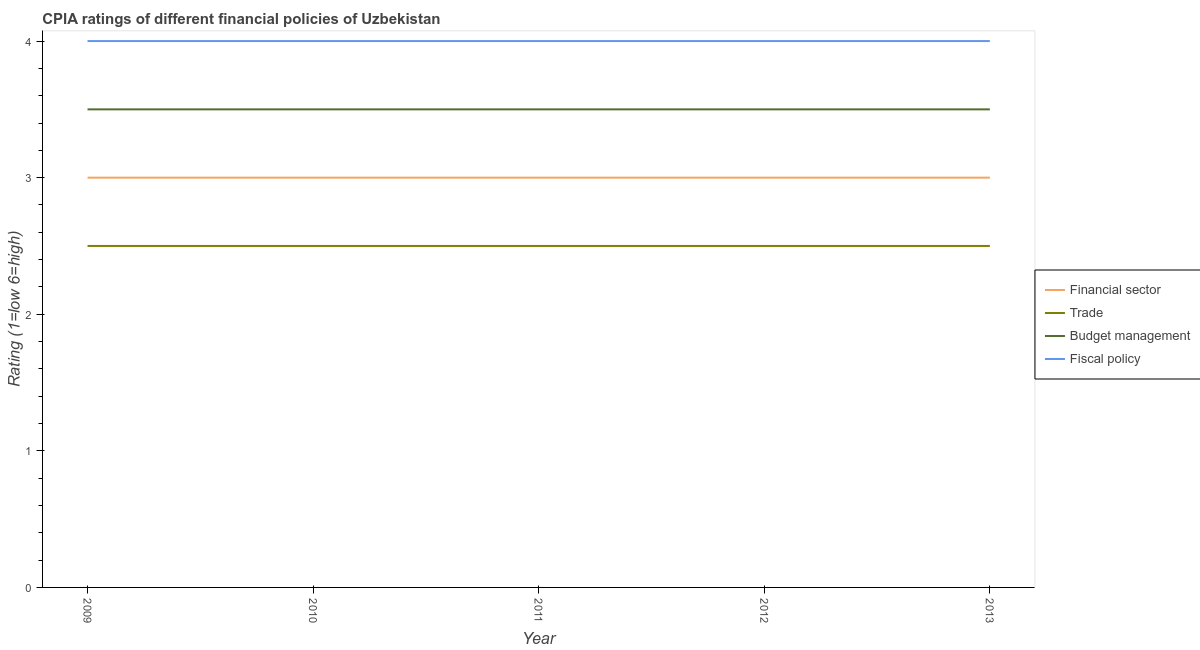How many different coloured lines are there?
Ensure brevity in your answer.  4. Is the number of lines equal to the number of legend labels?
Provide a succinct answer. Yes. What is the cpia rating of budget management in 2011?
Your answer should be very brief. 3.5. In which year was the cpia rating of fiscal policy maximum?
Your answer should be compact. 2009. What is the total cpia rating of budget management in the graph?
Offer a terse response. 17.5. In the year 2010, what is the difference between the cpia rating of fiscal policy and cpia rating of budget management?
Give a very brief answer. 0.5. Is the difference between the cpia rating of budget management in 2010 and 2013 greater than the difference between the cpia rating of fiscal policy in 2010 and 2013?
Your answer should be very brief. No. What is the difference between the highest and the second highest cpia rating of budget management?
Your response must be concise. 0. What is the difference between the highest and the lowest cpia rating of trade?
Give a very brief answer. 0. Is it the case that in every year, the sum of the cpia rating of financial sector and cpia rating of trade is greater than the cpia rating of budget management?
Give a very brief answer. Yes. Is the cpia rating of budget management strictly greater than the cpia rating of trade over the years?
Your answer should be very brief. Yes. Is the cpia rating of budget management strictly less than the cpia rating of fiscal policy over the years?
Your answer should be very brief. Yes. How many years are there in the graph?
Keep it short and to the point. 5. What is the difference between two consecutive major ticks on the Y-axis?
Give a very brief answer. 1. Does the graph contain any zero values?
Your answer should be very brief. No. Where does the legend appear in the graph?
Your answer should be compact. Center right. How are the legend labels stacked?
Offer a terse response. Vertical. What is the title of the graph?
Your response must be concise. CPIA ratings of different financial policies of Uzbekistan. What is the label or title of the X-axis?
Offer a very short reply. Year. What is the label or title of the Y-axis?
Offer a terse response. Rating (1=low 6=high). What is the Rating (1=low 6=high) in Financial sector in 2009?
Your response must be concise. 3. What is the Rating (1=low 6=high) in Budget management in 2009?
Your answer should be very brief. 3.5. What is the Rating (1=low 6=high) in Fiscal policy in 2009?
Keep it short and to the point. 4. What is the Rating (1=low 6=high) of Financial sector in 2010?
Give a very brief answer. 3. What is the Rating (1=low 6=high) of Budget management in 2010?
Provide a succinct answer. 3.5. What is the Rating (1=low 6=high) in Fiscal policy in 2010?
Provide a short and direct response. 4. What is the Rating (1=low 6=high) of Budget management in 2011?
Keep it short and to the point. 3.5. What is the Rating (1=low 6=high) of Budget management in 2012?
Offer a very short reply. 3.5. What is the Rating (1=low 6=high) in Financial sector in 2013?
Your answer should be very brief. 3. What is the Rating (1=low 6=high) in Trade in 2013?
Provide a short and direct response. 2.5. What is the Rating (1=low 6=high) of Budget management in 2013?
Give a very brief answer. 3.5. What is the Rating (1=low 6=high) of Fiscal policy in 2013?
Give a very brief answer. 4. Across all years, what is the maximum Rating (1=low 6=high) of Trade?
Provide a short and direct response. 2.5. Across all years, what is the minimum Rating (1=low 6=high) of Financial sector?
Your answer should be very brief. 3. Across all years, what is the minimum Rating (1=low 6=high) in Trade?
Keep it short and to the point. 2.5. Across all years, what is the minimum Rating (1=low 6=high) of Budget management?
Offer a very short reply. 3.5. What is the total Rating (1=low 6=high) of Trade in the graph?
Ensure brevity in your answer.  12.5. What is the total Rating (1=low 6=high) of Budget management in the graph?
Make the answer very short. 17.5. What is the difference between the Rating (1=low 6=high) of Fiscal policy in 2009 and that in 2010?
Provide a short and direct response. 0. What is the difference between the Rating (1=low 6=high) of Trade in 2009 and that in 2011?
Keep it short and to the point. 0. What is the difference between the Rating (1=low 6=high) in Budget management in 2009 and that in 2011?
Your response must be concise. 0. What is the difference between the Rating (1=low 6=high) of Financial sector in 2009 and that in 2012?
Give a very brief answer. 0. What is the difference between the Rating (1=low 6=high) in Budget management in 2009 and that in 2012?
Give a very brief answer. 0. What is the difference between the Rating (1=low 6=high) in Financial sector in 2009 and that in 2013?
Your response must be concise. 0. What is the difference between the Rating (1=low 6=high) of Budget management in 2009 and that in 2013?
Your answer should be very brief. 0. What is the difference between the Rating (1=low 6=high) of Trade in 2010 and that in 2011?
Provide a succinct answer. 0. What is the difference between the Rating (1=low 6=high) of Budget management in 2010 and that in 2011?
Make the answer very short. 0. What is the difference between the Rating (1=low 6=high) of Financial sector in 2010 and that in 2012?
Your answer should be compact. 0. What is the difference between the Rating (1=low 6=high) of Trade in 2010 and that in 2012?
Ensure brevity in your answer.  0. What is the difference between the Rating (1=low 6=high) of Budget management in 2010 and that in 2012?
Your response must be concise. 0. What is the difference between the Rating (1=low 6=high) in Fiscal policy in 2010 and that in 2012?
Offer a very short reply. 0. What is the difference between the Rating (1=low 6=high) of Budget management in 2010 and that in 2013?
Provide a succinct answer. 0. What is the difference between the Rating (1=low 6=high) of Fiscal policy in 2010 and that in 2013?
Give a very brief answer. 0. What is the difference between the Rating (1=low 6=high) of Fiscal policy in 2011 and that in 2012?
Provide a short and direct response. 0. What is the difference between the Rating (1=low 6=high) of Financial sector in 2011 and that in 2013?
Your response must be concise. 0. What is the difference between the Rating (1=low 6=high) of Fiscal policy in 2011 and that in 2013?
Keep it short and to the point. 0. What is the difference between the Rating (1=low 6=high) in Financial sector in 2009 and the Rating (1=low 6=high) in Budget management in 2010?
Provide a short and direct response. -0.5. What is the difference between the Rating (1=low 6=high) of Financial sector in 2009 and the Rating (1=low 6=high) of Fiscal policy in 2010?
Your answer should be compact. -1. What is the difference between the Rating (1=low 6=high) in Trade in 2009 and the Rating (1=low 6=high) in Fiscal policy in 2010?
Offer a very short reply. -1.5. What is the difference between the Rating (1=low 6=high) of Financial sector in 2009 and the Rating (1=low 6=high) of Trade in 2011?
Keep it short and to the point. 0.5. What is the difference between the Rating (1=low 6=high) of Financial sector in 2009 and the Rating (1=low 6=high) of Budget management in 2011?
Provide a short and direct response. -0.5. What is the difference between the Rating (1=low 6=high) in Financial sector in 2009 and the Rating (1=low 6=high) in Fiscal policy in 2011?
Offer a very short reply. -1. What is the difference between the Rating (1=low 6=high) in Trade in 2009 and the Rating (1=low 6=high) in Budget management in 2011?
Provide a short and direct response. -1. What is the difference between the Rating (1=low 6=high) of Budget management in 2009 and the Rating (1=low 6=high) of Fiscal policy in 2011?
Keep it short and to the point. -0.5. What is the difference between the Rating (1=low 6=high) in Financial sector in 2009 and the Rating (1=low 6=high) in Trade in 2012?
Keep it short and to the point. 0.5. What is the difference between the Rating (1=low 6=high) of Financial sector in 2009 and the Rating (1=low 6=high) of Fiscal policy in 2012?
Offer a very short reply. -1. What is the difference between the Rating (1=low 6=high) in Trade in 2009 and the Rating (1=low 6=high) in Budget management in 2012?
Provide a short and direct response. -1. What is the difference between the Rating (1=low 6=high) of Trade in 2009 and the Rating (1=low 6=high) of Fiscal policy in 2012?
Your answer should be very brief. -1.5. What is the difference between the Rating (1=low 6=high) of Budget management in 2009 and the Rating (1=low 6=high) of Fiscal policy in 2012?
Your answer should be compact. -0.5. What is the difference between the Rating (1=low 6=high) in Financial sector in 2009 and the Rating (1=low 6=high) in Budget management in 2013?
Give a very brief answer. -0.5. What is the difference between the Rating (1=low 6=high) in Budget management in 2009 and the Rating (1=low 6=high) in Fiscal policy in 2013?
Your response must be concise. -0.5. What is the difference between the Rating (1=low 6=high) of Trade in 2010 and the Rating (1=low 6=high) of Budget management in 2011?
Give a very brief answer. -1. What is the difference between the Rating (1=low 6=high) of Budget management in 2010 and the Rating (1=low 6=high) of Fiscal policy in 2011?
Make the answer very short. -0.5. What is the difference between the Rating (1=low 6=high) in Financial sector in 2010 and the Rating (1=low 6=high) in Trade in 2012?
Your response must be concise. 0.5. What is the difference between the Rating (1=low 6=high) of Financial sector in 2010 and the Rating (1=low 6=high) of Budget management in 2012?
Offer a very short reply. -0.5. What is the difference between the Rating (1=low 6=high) in Financial sector in 2010 and the Rating (1=low 6=high) in Fiscal policy in 2012?
Give a very brief answer. -1. What is the difference between the Rating (1=low 6=high) of Trade in 2010 and the Rating (1=low 6=high) of Budget management in 2012?
Offer a terse response. -1. What is the difference between the Rating (1=low 6=high) in Trade in 2010 and the Rating (1=low 6=high) in Fiscal policy in 2012?
Your answer should be very brief. -1.5. What is the difference between the Rating (1=low 6=high) in Trade in 2010 and the Rating (1=low 6=high) in Fiscal policy in 2013?
Provide a short and direct response. -1.5. What is the difference between the Rating (1=low 6=high) in Budget management in 2010 and the Rating (1=low 6=high) in Fiscal policy in 2013?
Provide a short and direct response. -0.5. What is the difference between the Rating (1=low 6=high) of Financial sector in 2011 and the Rating (1=low 6=high) of Trade in 2012?
Keep it short and to the point. 0.5. What is the difference between the Rating (1=low 6=high) in Financial sector in 2011 and the Rating (1=low 6=high) in Fiscal policy in 2012?
Give a very brief answer. -1. What is the difference between the Rating (1=low 6=high) in Trade in 2011 and the Rating (1=low 6=high) in Budget management in 2012?
Keep it short and to the point. -1. What is the difference between the Rating (1=low 6=high) in Trade in 2011 and the Rating (1=low 6=high) in Fiscal policy in 2013?
Provide a short and direct response. -1.5. What is the difference between the Rating (1=low 6=high) of Financial sector in 2012 and the Rating (1=low 6=high) of Trade in 2013?
Make the answer very short. 0.5. What is the difference between the Rating (1=low 6=high) in Financial sector in 2012 and the Rating (1=low 6=high) in Fiscal policy in 2013?
Your answer should be compact. -1. What is the difference between the Rating (1=low 6=high) in Trade in 2012 and the Rating (1=low 6=high) in Fiscal policy in 2013?
Your answer should be compact. -1.5. What is the average Rating (1=low 6=high) in Financial sector per year?
Give a very brief answer. 3. What is the average Rating (1=low 6=high) in Budget management per year?
Offer a terse response. 3.5. In the year 2009, what is the difference between the Rating (1=low 6=high) in Financial sector and Rating (1=low 6=high) in Fiscal policy?
Provide a succinct answer. -1. In the year 2009, what is the difference between the Rating (1=low 6=high) in Trade and Rating (1=low 6=high) in Fiscal policy?
Your response must be concise. -1.5. In the year 2009, what is the difference between the Rating (1=low 6=high) in Budget management and Rating (1=low 6=high) in Fiscal policy?
Your answer should be very brief. -0.5. In the year 2010, what is the difference between the Rating (1=low 6=high) of Financial sector and Rating (1=low 6=high) of Trade?
Offer a terse response. 0.5. In the year 2010, what is the difference between the Rating (1=low 6=high) in Budget management and Rating (1=low 6=high) in Fiscal policy?
Your answer should be compact. -0.5. In the year 2011, what is the difference between the Rating (1=low 6=high) in Trade and Rating (1=low 6=high) in Budget management?
Offer a very short reply. -1. In the year 2011, what is the difference between the Rating (1=low 6=high) in Budget management and Rating (1=low 6=high) in Fiscal policy?
Your response must be concise. -0.5. In the year 2012, what is the difference between the Rating (1=low 6=high) in Financial sector and Rating (1=low 6=high) in Trade?
Provide a succinct answer. 0.5. In the year 2012, what is the difference between the Rating (1=low 6=high) in Financial sector and Rating (1=low 6=high) in Budget management?
Keep it short and to the point. -0.5. In the year 2012, what is the difference between the Rating (1=low 6=high) of Financial sector and Rating (1=low 6=high) of Fiscal policy?
Offer a terse response. -1. In the year 2012, what is the difference between the Rating (1=low 6=high) of Trade and Rating (1=low 6=high) of Budget management?
Offer a terse response. -1. In the year 2013, what is the difference between the Rating (1=low 6=high) in Financial sector and Rating (1=low 6=high) in Budget management?
Offer a very short reply. -0.5. In the year 2013, what is the difference between the Rating (1=low 6=high) of Trade and Rating (1=low 6=high) of Budget management?
Offer a terse response. -1. In the year 2013, what is the difference between the Rating (1=low 6=high) in Budget management and Rating (1=low 6=high) in Fiscal policy?
Your response must be concise. -0.5. What is the ratio of the Rating (1=low 6=high) of Trade in 2009 to that in 2010?
Offer a very short reply. 1. What is the ratio of the Rating (1=low 6=high) of Budget management in 2009 to that in 2010?
Your answer should be compact. 1. What is the ratio of the Rating (1=low 6=high) of Financial sector in 2009 to that in 2012?
Offer a terse response. 1. What is the ratio of the Rating (1=low 6=high) of Trade in 2009 to that in 2013?
Provide a succinct answer. 1. What is the ratio of the Rating (1=low 6=high) of Budget management in 2009 to that in 2013?
Offer a terse response. 1. What is the ratio of the Rating (1=low 6=high) of Fiscal policy in 2009 to that in 2013?
Keep it short and to the point. 1. What is the ratio of the Rating (1=low 6=high) of Financial sector in 2010 to that in 2011?
Give a very brief answer. 1. What is the ratio of the Rating (1=low 6=high) of Financial sector in 2010 to that in 2012?
Offer a terse response. 1. What is the ratio of the Rating (1=low 6=high) of Financial sector in 2010 to that in 2013?
Your answer should be very brief. 1. What is the ratio of the Rating (1=low 6=high) in Trade in 2010 to that in 2013?
Your response must be concise. 1. What is the ratio of the Rating (1=low 6=high) of Budget management in 2010 to that in 2013?
Your response must be concise. 1. What is the ratio of the Rating (1=low 6=high) in Fiscal policy in 2010 to that in 2013?
Your answer should be very brief. 1. What is the ratio of the Rating (1=low 6=high) of Financial sector in 2011 to that in 2012?
Your response must be concise. 1. What is the ratio of the Rating (1=low 6=high) of Budget management in 2011 to that in 2012?
Give a very brief answer. 1. What is the ratio of the Rating (1=low 6=high) of Financial sector in 2011 to that in 2013?
Provide a succinct answer. 1. What is the ratio of the Rating (1=low 6=high) in Trade in 2011 to that in 2013?
Keep it short and to the point. 1. What is the ratio of the Rating (1=low 6=high) in Budget management in 2011 to that in 2013?
Provide a succinct answer. 1. What is the ratio of the Rating (1=low 6=high) of Fiscal policy in 2012 to that in 2013?
Provide a short and direct response. 1. What is the difference between the highest and the second highest Rating (1=low 6=high) of Financial sector?
Provide a short and direct response. 0. What is the difference between the highest and the second highest Rating (1=low 6=high) of Trade?
Provide a succinct answer. 0. What is the difference between the highest and the second highest Rating (1=low 6=high) in Budget management?
Give a very brief answer. 0. What is the difference between the highest and the second highest Rating (1=low 6=high) in Fiscal policy?
Provide a short and direct response. 0. 